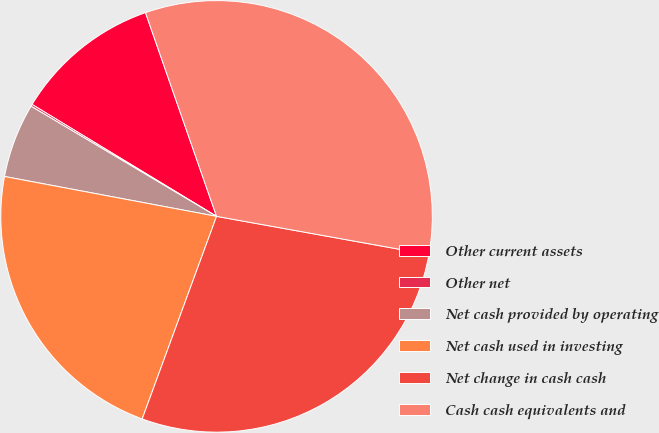Convert chart. <chart><loc_0><loc_0><loc_500><loc_500><pie_chart><fcel>Other current assets<fcel>Other net<fcel>Net cash provided by operating<fcel>Net cash used in investing<fcel>Net change in cash cash<fcel>Cash cash equivalents and<nl><fcel>10.98%<fcel>0.15%<fcel>5.57%<fcel>22.36%<fcel>27.77%<fcel>33.18%<nl></chart> 